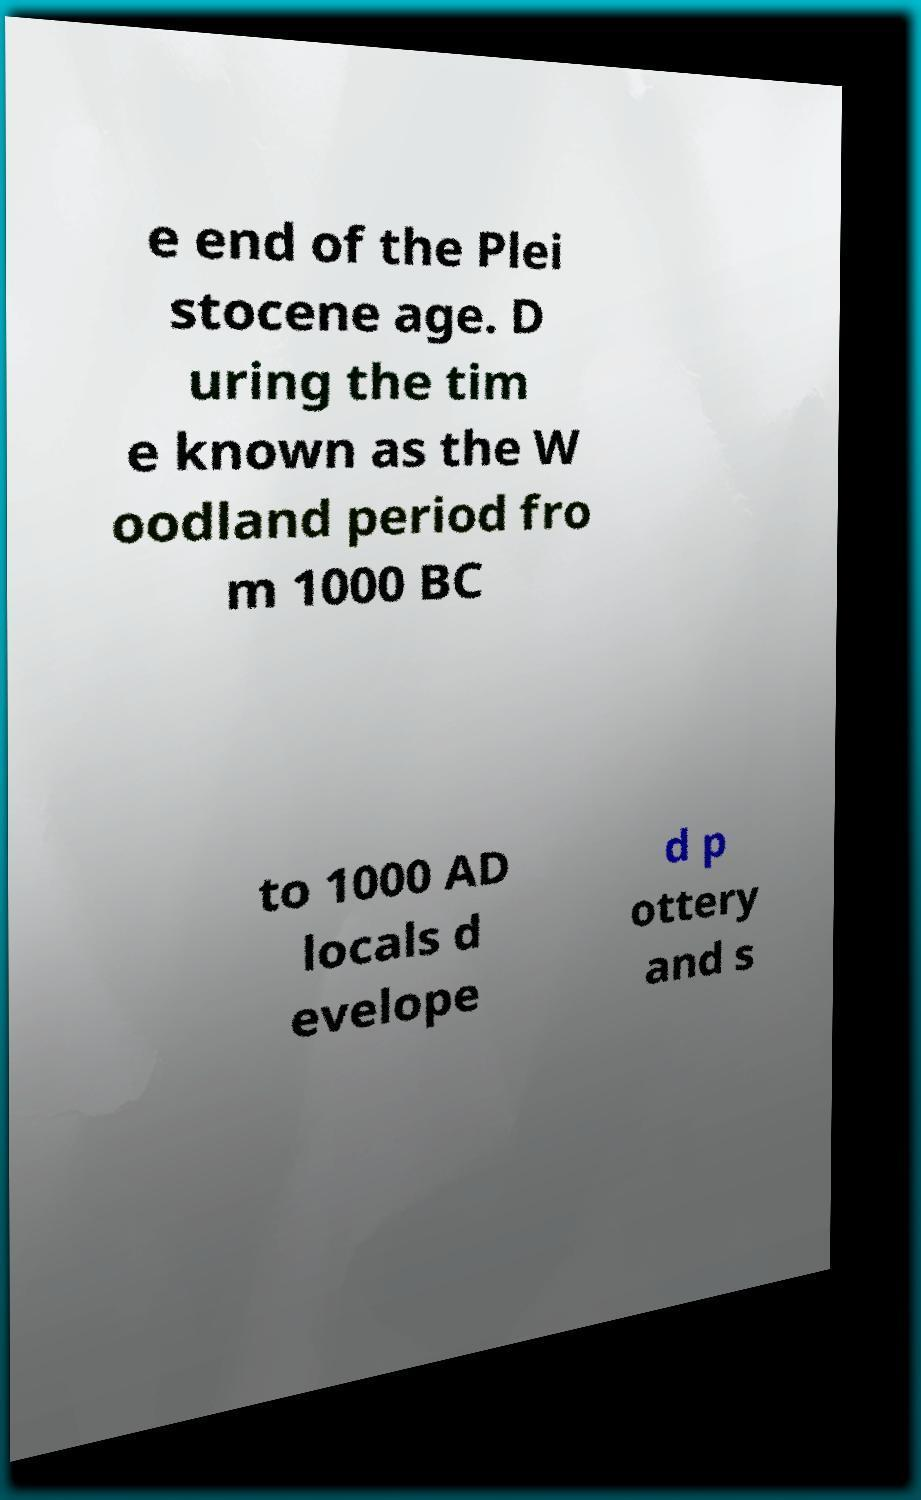Could you extract and type out the text from this image? e end of the Plei stocene age. D uring the tim e known as the W oodland period fro m 1000 BC to 1000 AD locals d evelope d p ottery and s 